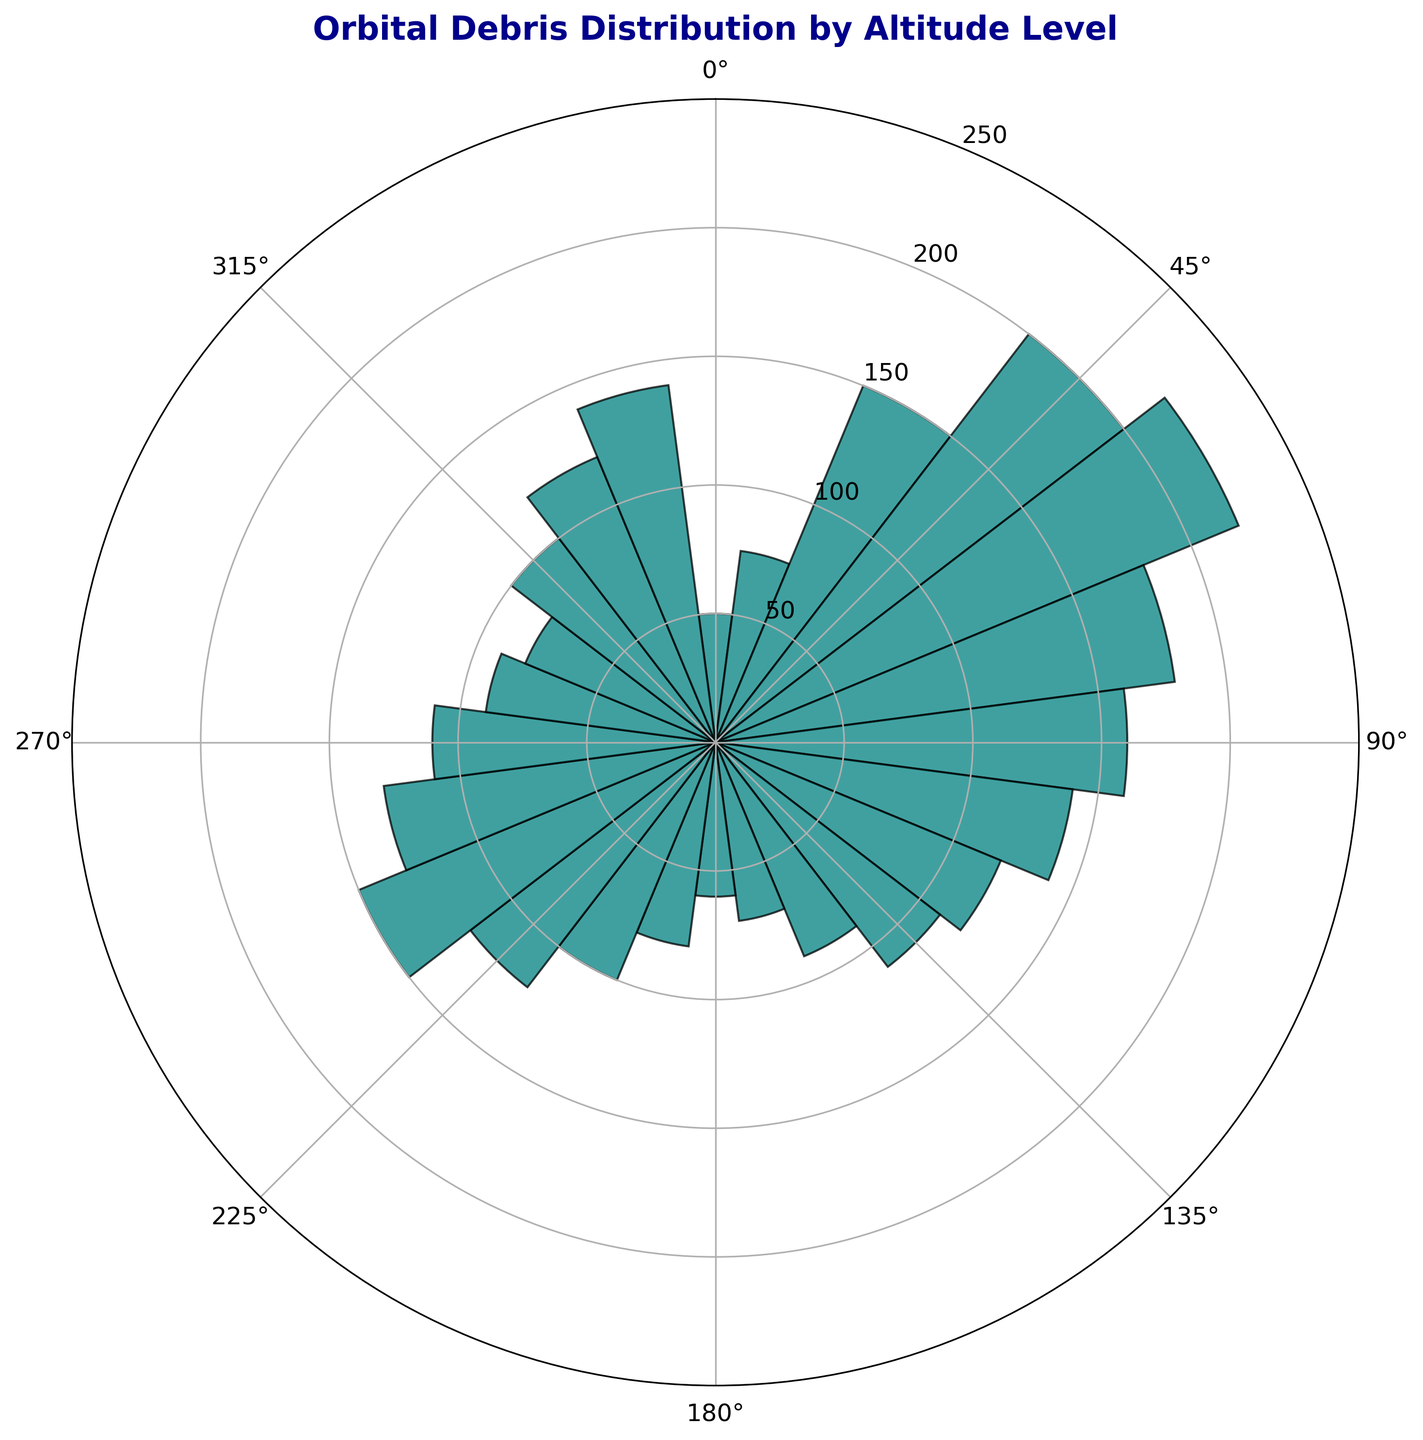Which altitude level has the highest count of orbital debris? The highest bar in the rose chart represents the altitude level with the greatest count of orbital debris. The bar aligns with the 60-degree mark.
Answer: 60 degrees What is the difference in debris count between the 60-degree and 180-degree altitude levels? The count at 60 degrees is 220 and at 180 degrees is 60. The difference is calculated by subtracting the latter from the former: 220 - 60 = 160.
Answer: 160 What is the average count of orbital debris across all altitude levels? Sum all the debris counts and divide by the number of data points. The total sum is 2625, with 24 data points. The average is 2625 / 24 = 109.375.
Answer: 109.375 Of the altitude levels 30 degrees and 240 degrees, which has more orbital debris? Compare the bar heights at 30 degrees (150) and 240 degrees (150).
Answer: Both have the same count What is the total debris count from 0 degrees to 90 degrees? Sum the counts at 0 degrees (50), 15 degrees (75), 30 degrees (150), 45 degrees (200), 60 degrees (220), 75 degrees (180), 90 degrees (160). 50 + 75 + 150 + 200 + 220 + 180 + 160 = 1035.
Answer: 1035 Which altitude levels have a debris count less than 100? Identify bars that are shorter than the radial grid line for 100 units. These are 0 degrees (50), 15 degrees (75), 165 degrees (70), 180 degrees (60), 195 degrees (80), 285 degrees (90), 300 degrees (80).
Answer: 0, 15, 165, 180, 195, 285, 300 degrees Is there any altitude level with exactly 120 debris? Check for any bar that matches the 120 units radial grid. The bars at 120 degrees, 225 degrees, and 330 degrees align with this count.
Answer: Yes What is the sum of debris counts at 105 degrees and 315 degrees? The counts at 105 degrees and 315 degrees are 140 and 100 respectively. 140 + 100 = 240.
Answer: 240 How many altitude levels have a count greater than 150? Count the bars exceeding the 150 units radial grid line. These are at 30 degrees, 45 degrees, 60 degrees, 240 degrees.
Answer: 4 At which altitude level does the count drop from its previous level's count for the first time? Starting from 0 degrees, 15 degrees shows an increase. The first decrease happens from 60 degrees (220) to 75 degrees (180).
Answer: 75 degrees 